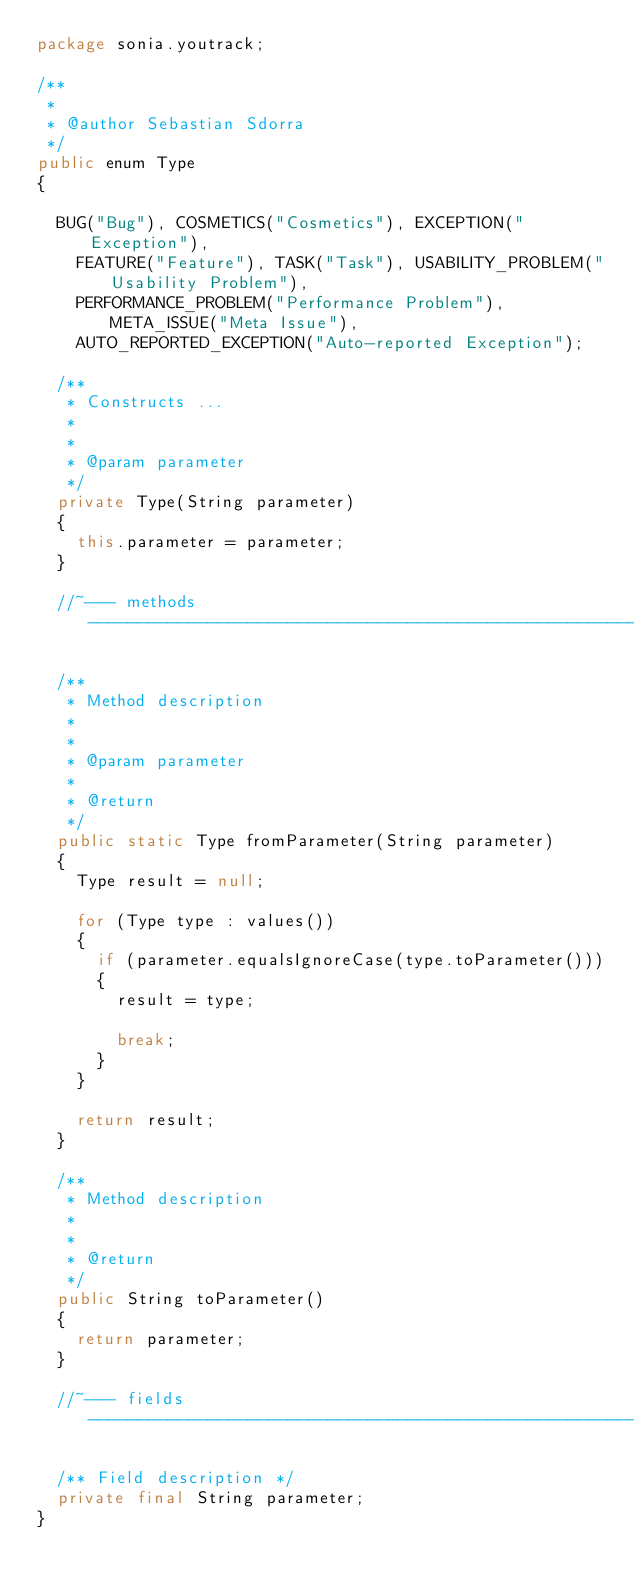<code> <loc_0><loc_0><loc_500><loc_500><_Java_>package sonia.youtrack;

/**
 *
 * @author Sebastian Sdorra
 */
public enum Type
{

  BUG("Bug"), COSMETICS("Cosmetics"), EXCEPTION("Exception"),
    FEATURE("Feature"), TASK("Task"), USABILITY_PROBLEM("Usability Problem"),
    PERFORMANCE_PROBLEM("Performance Problem"), META_ISSUE("Meta Issue"),
    AUTO_REPORTED_EXCEPTION("Auto-reported Exception");

  /**
   * Constructs ...
   *
   *
   * @param parameter
   */
  private Type(String parameter)
  {
    this.parameter = parameter;
  }

  //~--- methods --------------------------------------------------------------

  /**
   * Method description
   *
   *
   * @param parameter
   *
   * @return
   */
  public static Type fromParameter(String parameter)
  {
    Type result = null;

    for (Type type : values())
    {
      if (parameter.equalsIgnoreCase(type.toParameter()))
      {
        result = type;

        break;
      }
    }

    return result;
  }

  /**
   * Method description
   *
   *
   * @return
   */
  public String toParameter()
  {
    return parameter;
  }

  //~--- fields ---------------------------------------------------------------

  /** Field description */
  private final String parameter;
}
</code> 